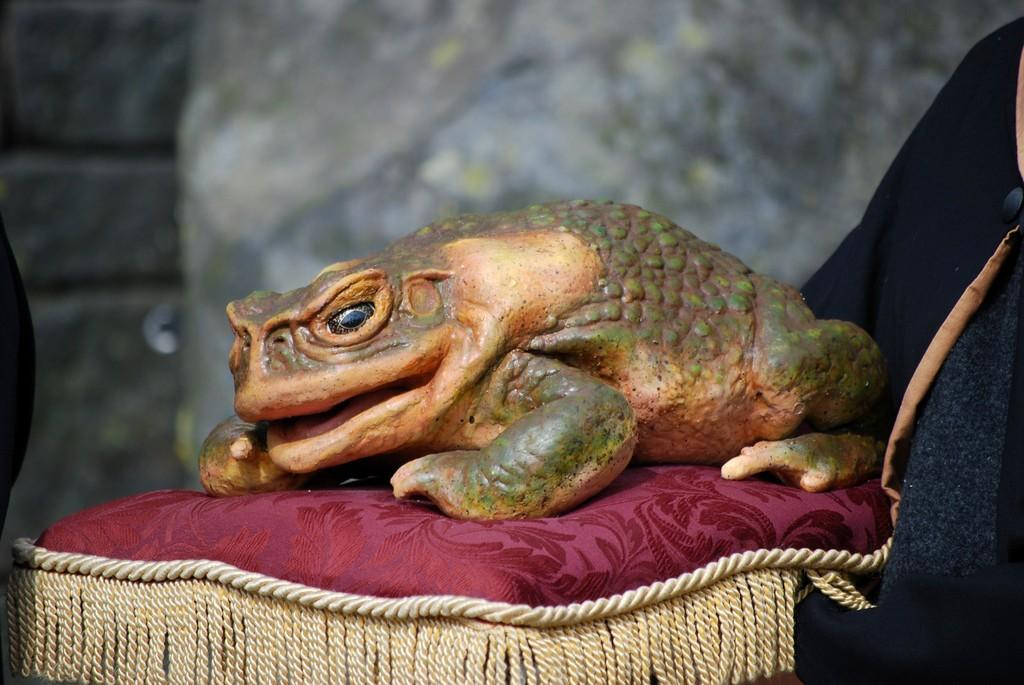What type of toy is in the image? There is a toy frog in the image. Where is the toy frog located? The toy frog is on a chair. Can you describe the background of the image? The background of the image is blurred. What type of pies can be seen in the image? There are no pies present in the image; it features a toy frog on a chair with a blurred background. 